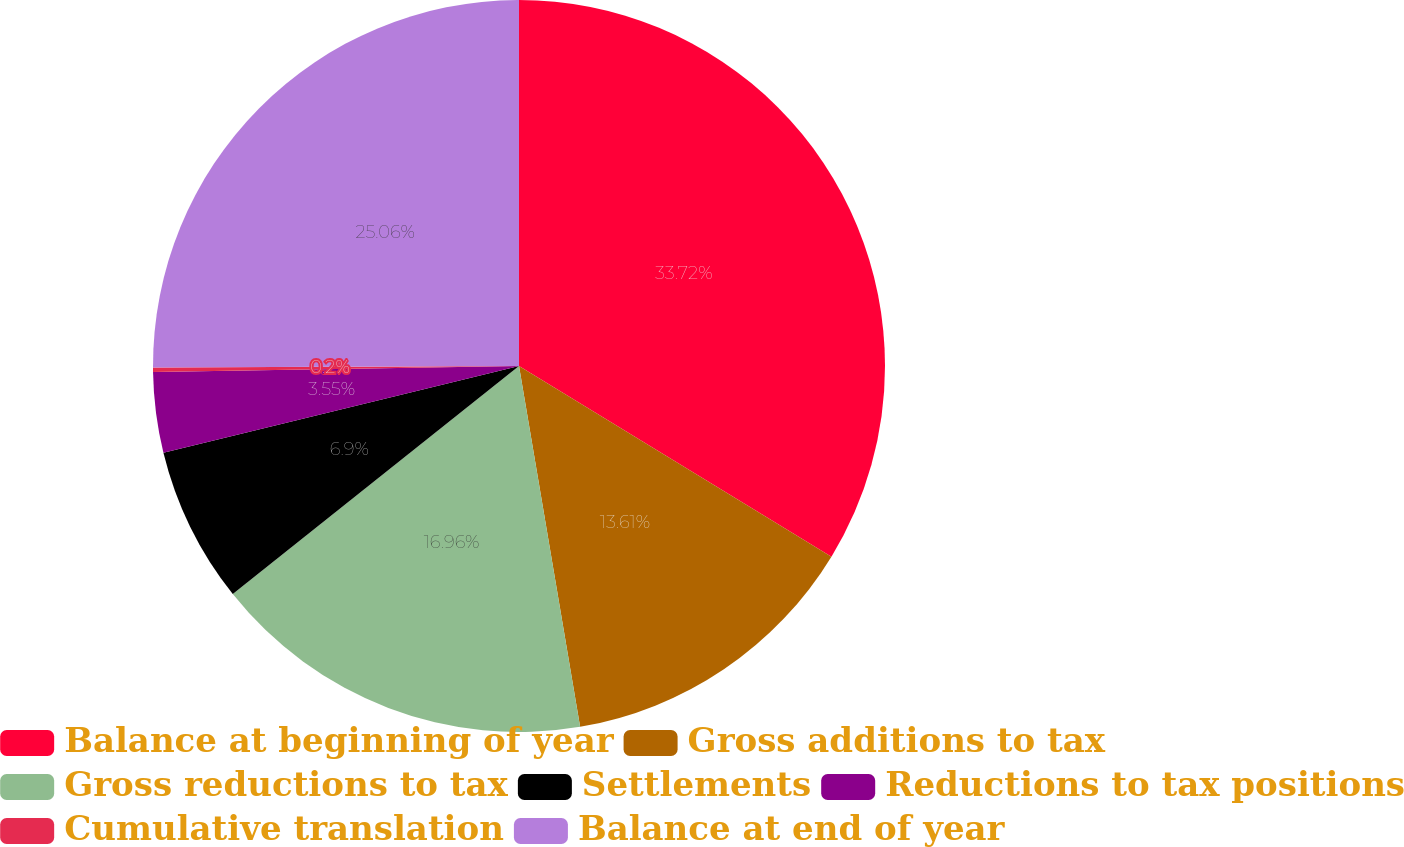<chart> <loc_0><loc_0><loc_500><loc_500><pie_chart><fcel>Balance at beginning of year<fcel>Gross additions to tax<fcel>Gross reductions to tax<fcel>Settlements<fcel>Reductions to tax positions<fcel>Cumulative translation<fcel>Balance at end of year<nl><fcel>33.72%<fcel>13.61%<fcel>16.96%<fcel>6.9%<fcel>3.55%<fcel>0.2%<fcel>25.06%<nl></chart> 